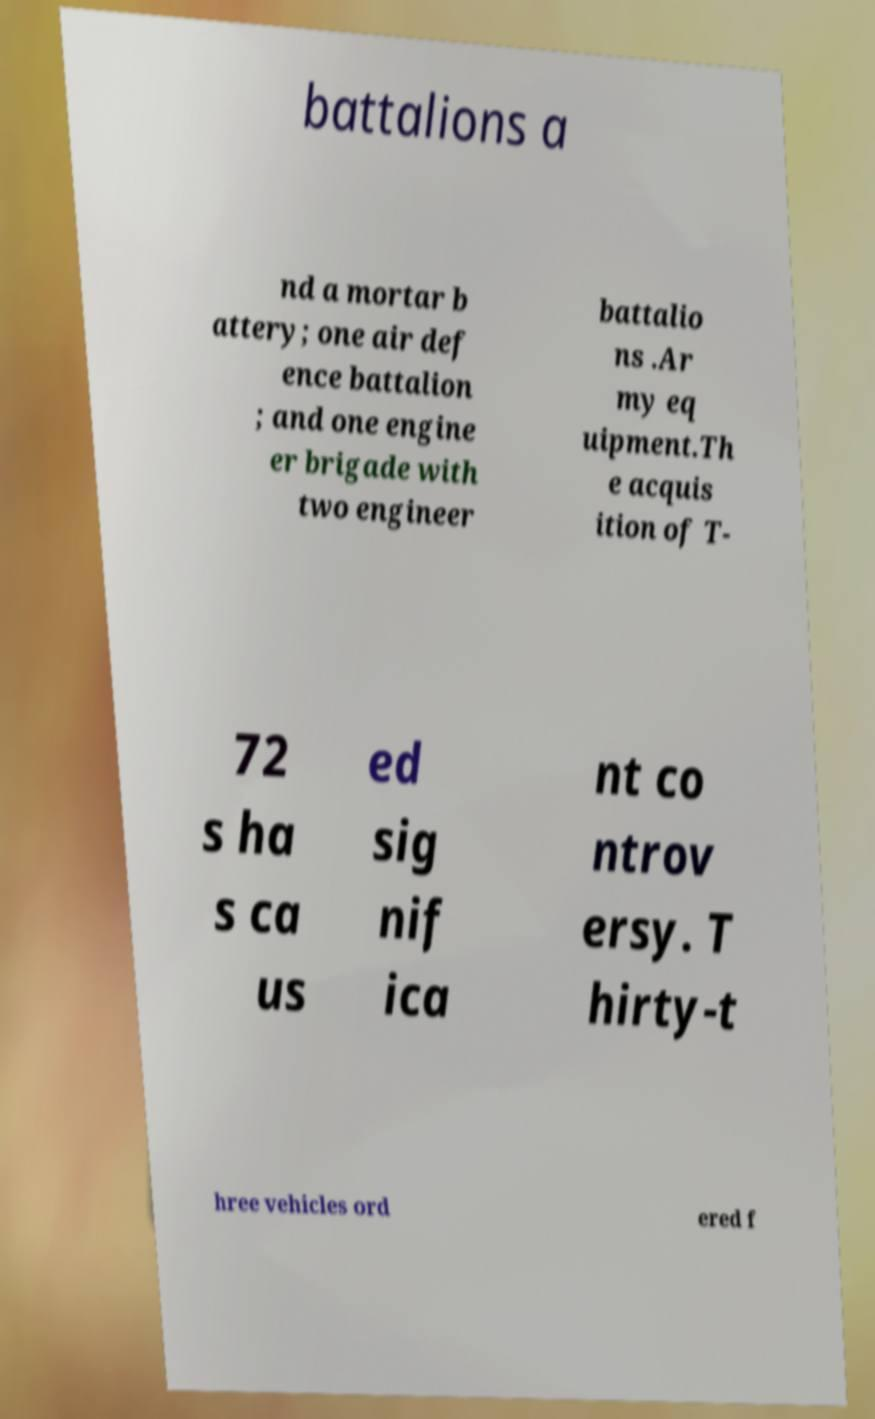What messages or text are displayed in this image? I need them in a readable, typed format. battalions a nd a mortar b attery; one air def ence battalion ; and one engine er brigade with two engineer battalio ns .Ar my eq uipment.Th e acquis ition of T- 72 s ha s ca us ed sig nif ica nt co ntrov ersy. T hirty-t hree vehicles ord ered f 